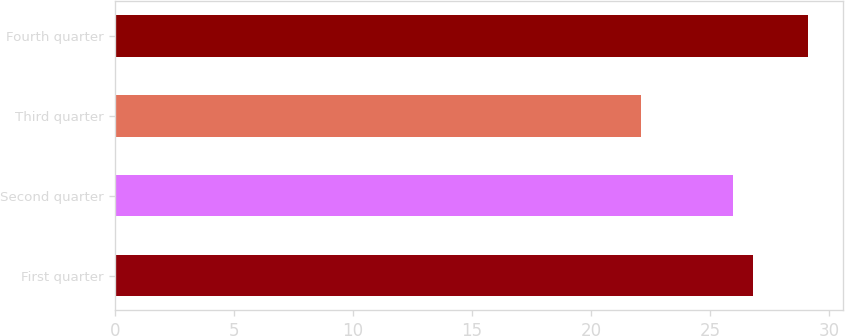Convert chart. <chart><loc_0><loc_0><loc_500><loc_500><bar_chart><fcel>First quarter<fcel>Second quarter<fcel>Third quarter<fcel>Fourth quarter<nl><fcel>26.8<fcel>25.99<fcel>22.1<fcel>29.14<nl></chart> 